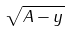<formula> <loc_0><loc_0><loc_500><loc_500>\sqrt { A - y }</formula> 